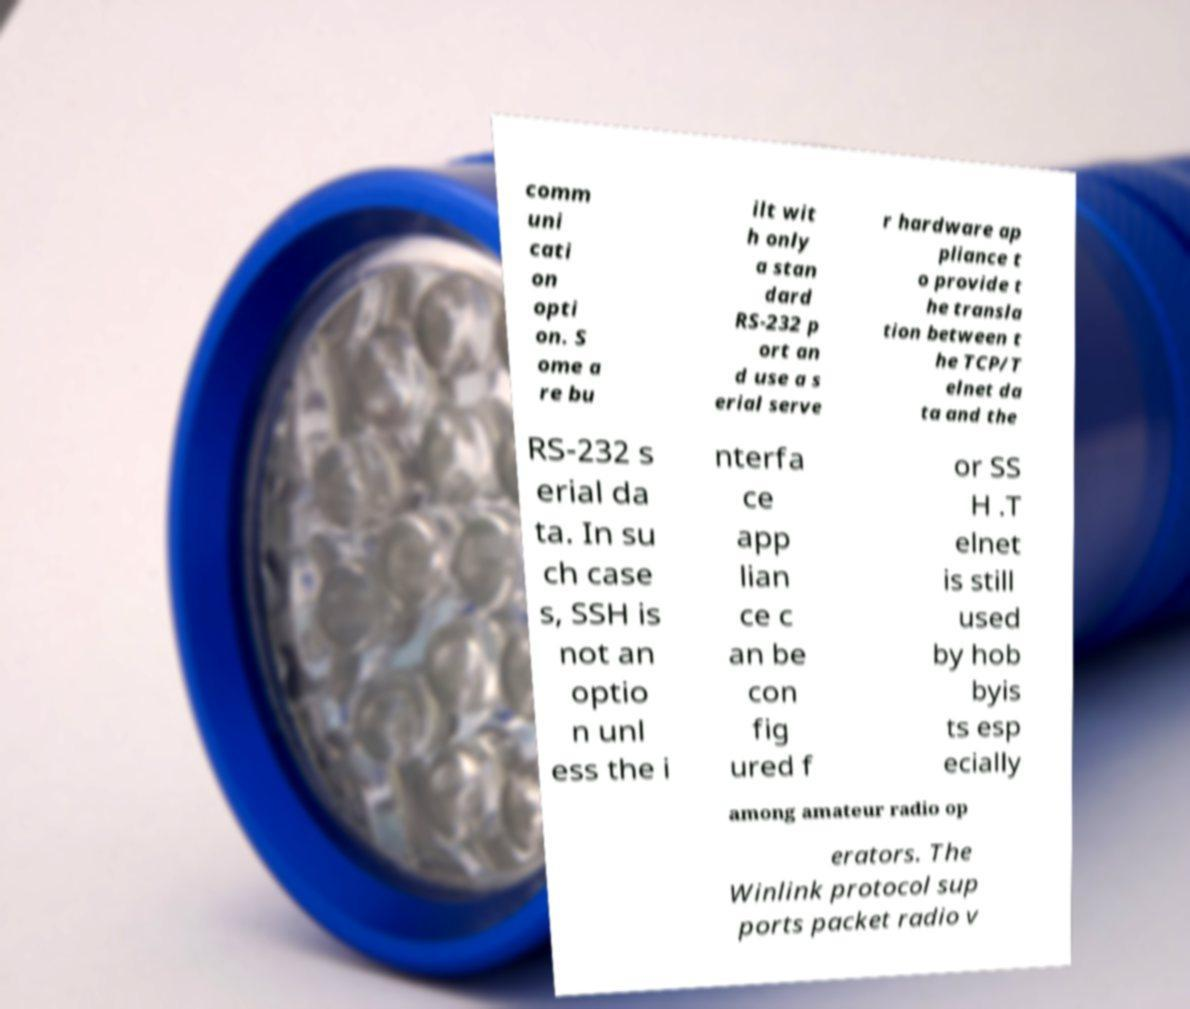I need the written content from this picture converted into text. Can you do that? comm uni cati on opti on. S ome a re bu ilt wit h only a stan dard RS-232 p ort an d use a s erial serve r hardware ap pliance t o provide t he transla tion between t he TCP/T elnet da ta and the RS-232 s erial da ta. In su ch case s, SSH is not an optio n unl ess the i nterfa ce app lian ce c an be con fig ured f or SS H .T elnet is still used by hob byis ts esp ecially among amateur radio op erators. The Winlink protocol sup ports packet radio v 